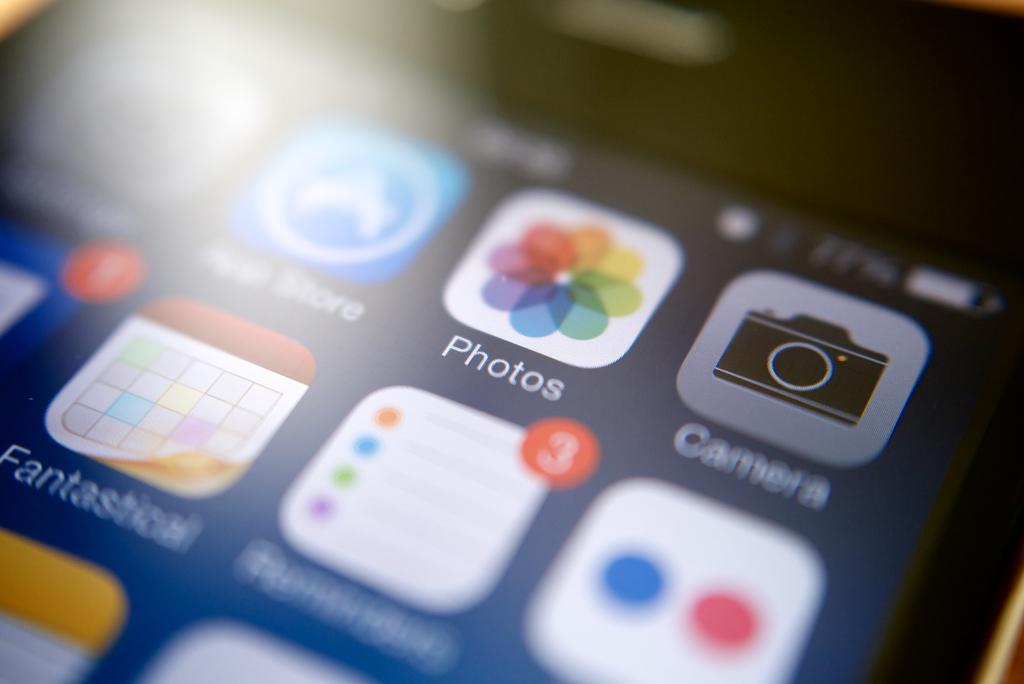What is one of the apps here for?
Your answer should be very brief. Photos. What can be done?
Provide a short and direct response. Photos. 